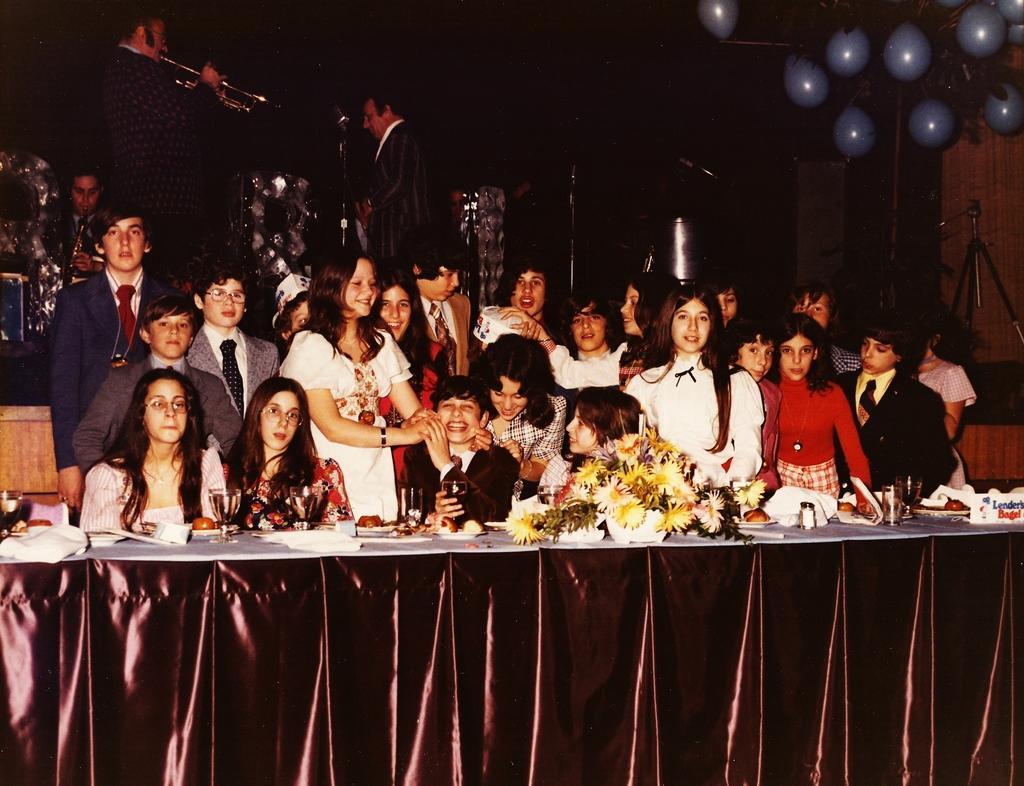Please provide a concise description of this image. In the foreground of this image, there is a table on which glasses, flower pot, tissue papers, platters and a name board are on it. In the background, there is the crowd standing and few of them are sitting and also few men standing and playing musical instruments in front of a mice. On the top right, there are balloons, a tripod stand and a wall. 